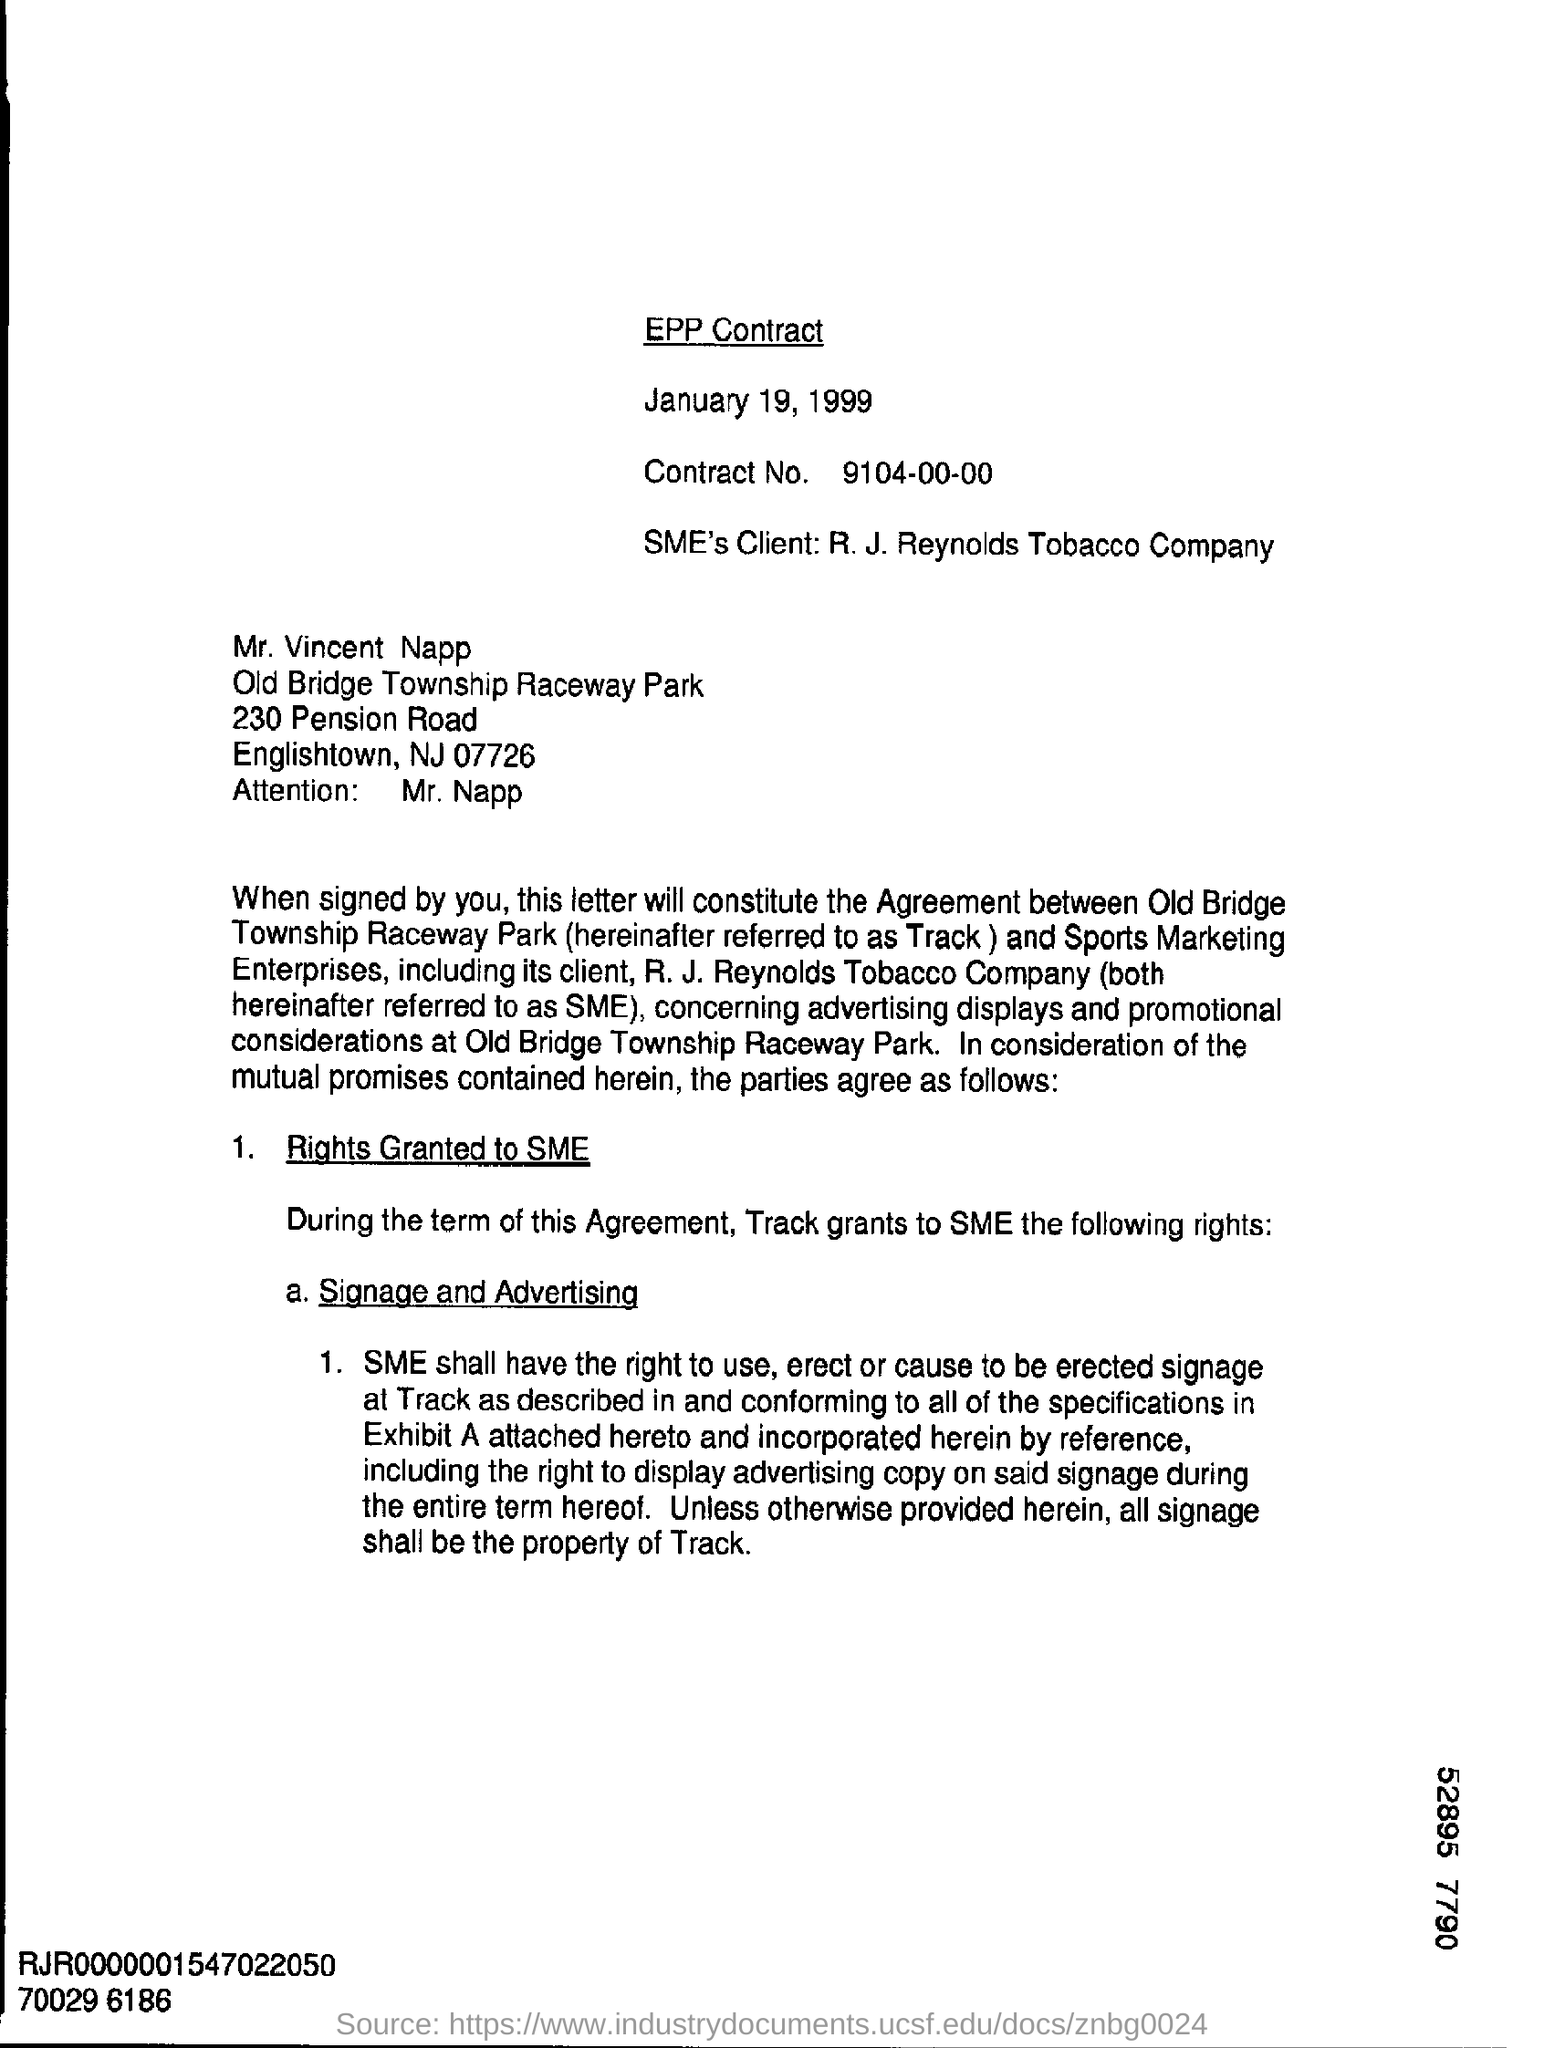Whose attention is invited in this letter? The letter is addressed to Mr. Vincent Napp, inviting his attention regarding the content of the EPP Contract. Mr. Napp is associated with Old Bridge Township Raceway Park, located at 230 Pension Road, Englishtown, NJ 07726. 